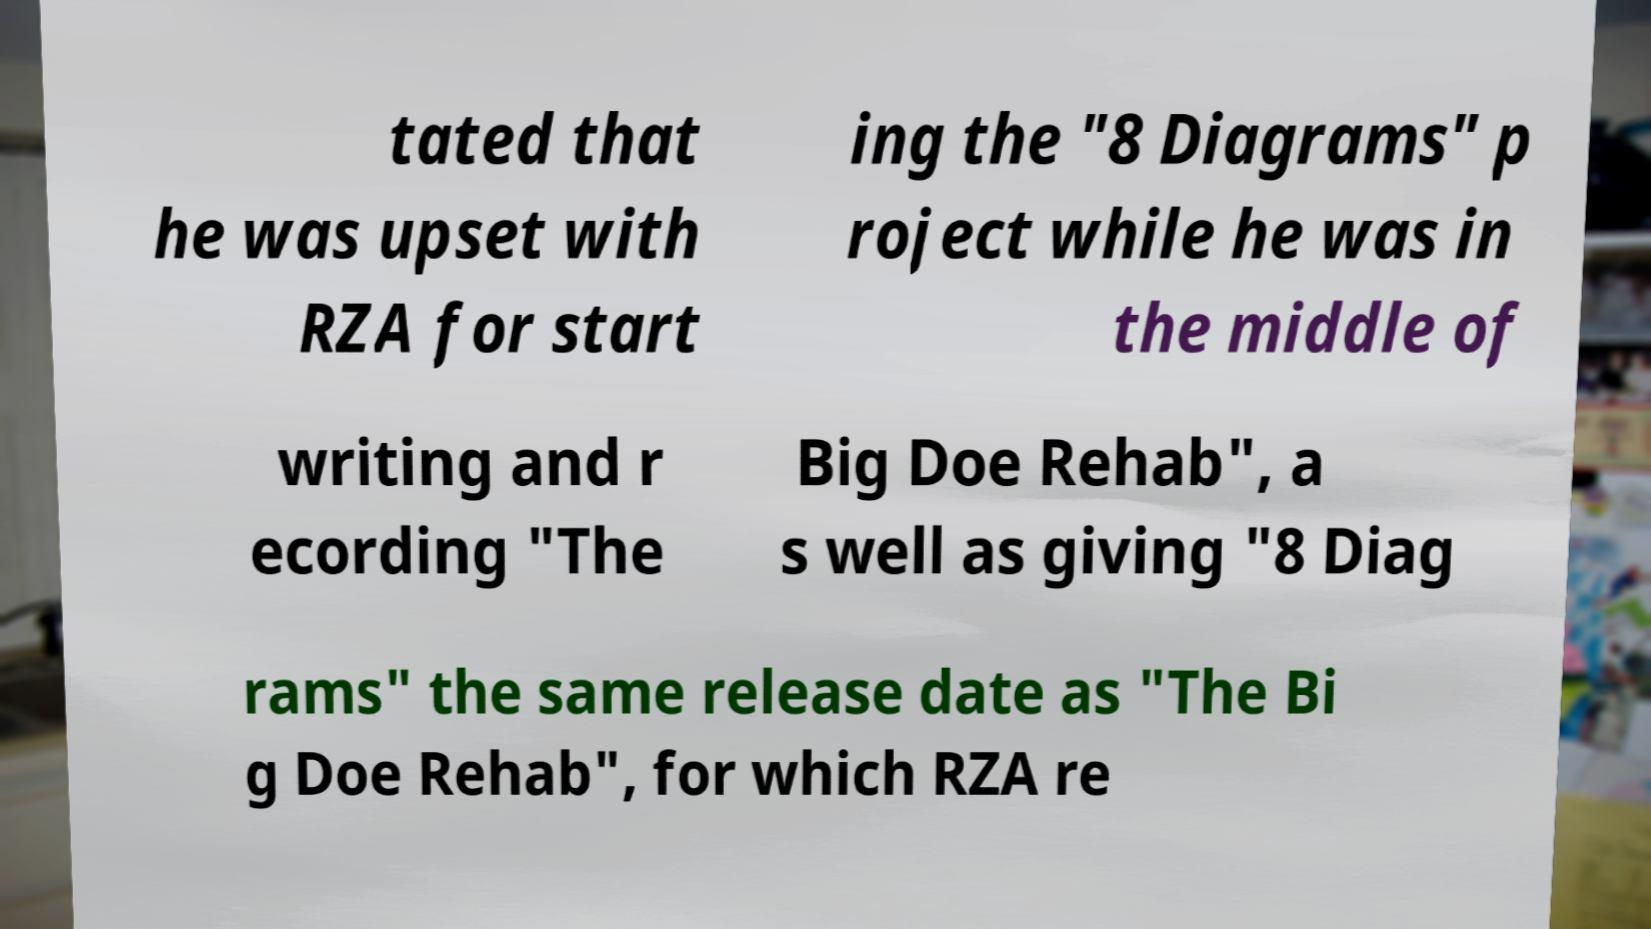Could you assist in decoding the text presented in this image and type it out clearly? tated that he was upset with RZA for start ing the "8 Diagrams" p roject while he was in the middle of writing and r ecording "The Big Doe Rehab", a s well as giving "8 Diag rams" the same release date as "The Bi g Doe Rehab", for which RZA re 